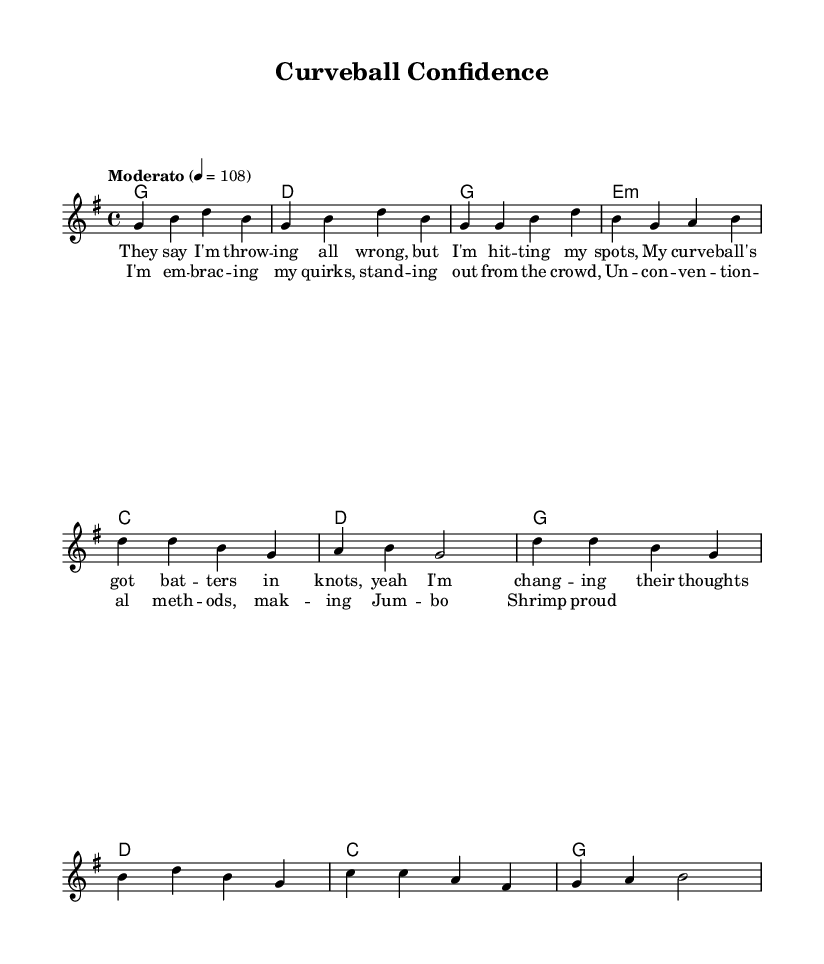What is the key signature of this music? The key signature is G major, which has one sharp (F#). This can be determined by looking at the key specified in the global settings at the top of the sheet music.
Answer: G major What is the time signature of the piece? The time signature is 4/4, indicating four beats per measure. This is evident from the "time" indication in the global settings, which specifies 4/4.
Answer: 4/4 What is the tempo marking given for the piece? The tempo is marked as "Moderato" at a speed of 108 beats per minute. This is noted in the "tempo" directive in the global section, which sets the pace for the music.
Answer: Moderato 4 = 108 What type of song structure does this piece primarily follow? The piece follows a Verse-Chorus structure, evident from the distinct sections labeled "Verse" and "Chorus" that alternate in the music.
Answer: Verse-Chorus How many measures are in the chorus? The chorus consists of two measures, which can be counted from the notation in the sheet music. Each line of the chorus corresponds to a measure, and the first two lines represent the chorus section.
Answer: 2 What is the subject of the lyrics in the verse? The lyrics of the verse discuss unconventional pitching techniques and the pitcher's confidence in their unique style. This can be understood by reading the lyrics provided under the melody, which highlight themes of self-confidence and strategy.
Answer: Unconventional pitching What is a key theme highlighted in the chorus lyrics? The chorus emphasizes embracing quirks and standing out from the crowd, which reflects the overarching theme of individuality in the song. This is directly indicated in the lyrics of the chorus.
Answer: Embracing quirks 